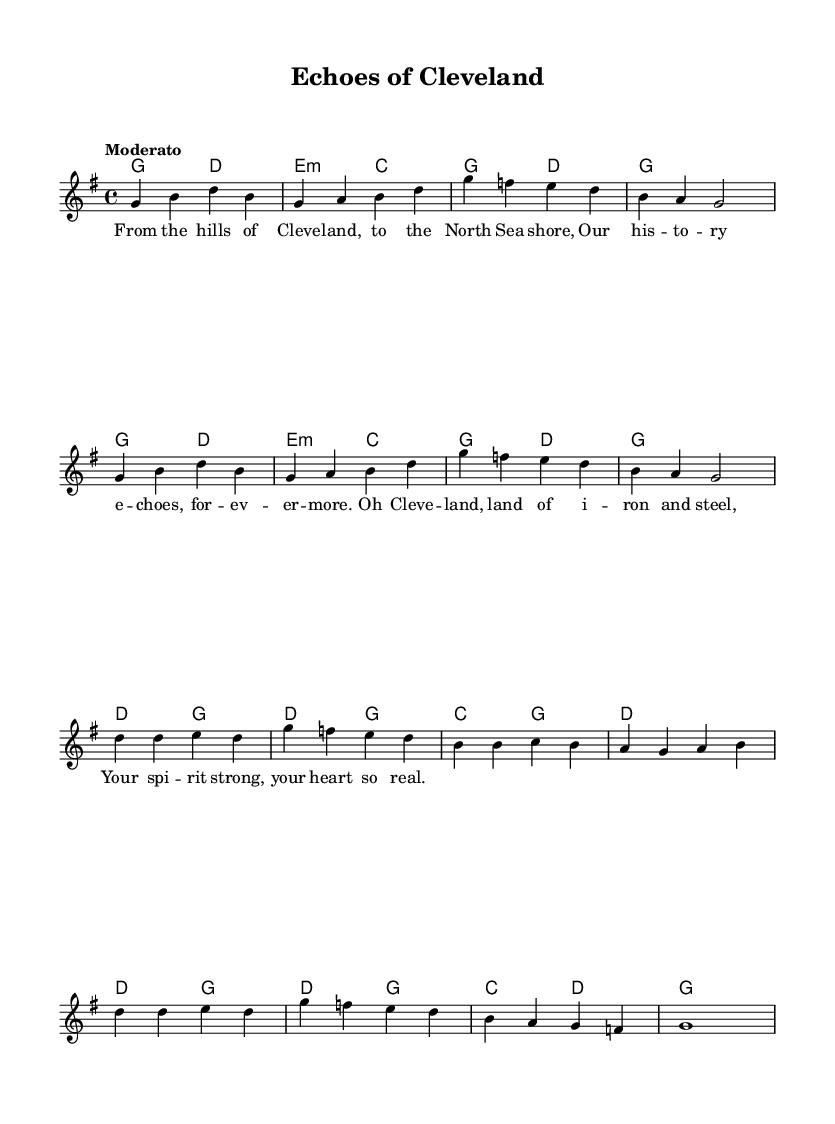What is the key signature of this music? The key signature is G major, indicated by an F sharp.
Answer: G major What is the time signature of this music? The time signature is 4/4, shown at the beginning of the piece.
Answer: 4/4 What is the tempo marking of the piece? The tempo marking is "Moderato," which indicates a moderate tempo speed.
Answer: Moderato How many measures are in the verse section? There are four measures in the verse section, as indicated by the organization of the melody notes.
Answer: Four What is the first note of the chorus? The first note of the chorus is D, which starts the melody after the verse.
Answer: D What chord is played with the last measure of the piece? The last measure contains a G major chord, which is noted in the harmony line.
Answer: G How many lines are in the lyrics of the verse? There are four lines in the lyrics of the verse as indicated by the structure of the lyrics under the melody.
Answer: Four 